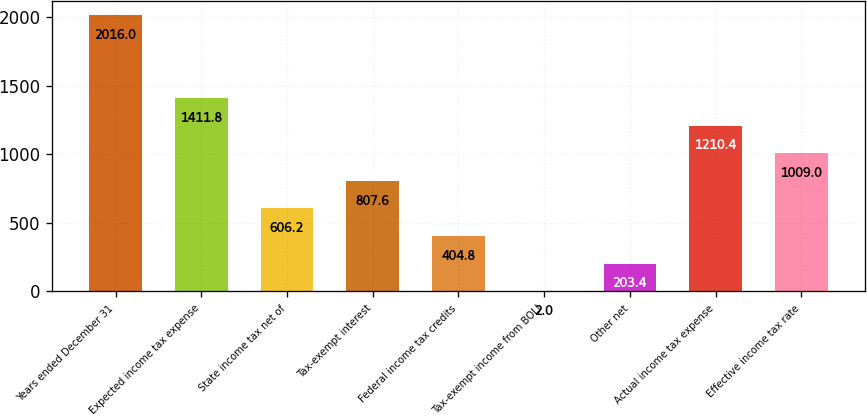Convert chart. <chart><loc_0><loc_0><loc_500><loc_500><bar_chart><fcel>Years ended December 31<fcel>Expected income tax expense<fcel>State income tax net of<fcel>Tax-exempt interest<fcel>Federal income tax credits<fcel>Tax-exempt income from BOLI<fcel>Other net<fcel>Actual income tax expense<fcel>Effective income tax rate<nl><fcel>2016<fcel>1411.8<fcel>606.2<fcel>807.6<fcel>404.8<fcel>2<fcel>203.4<fcel>1210.4<fcel>1009<nl></chart> 